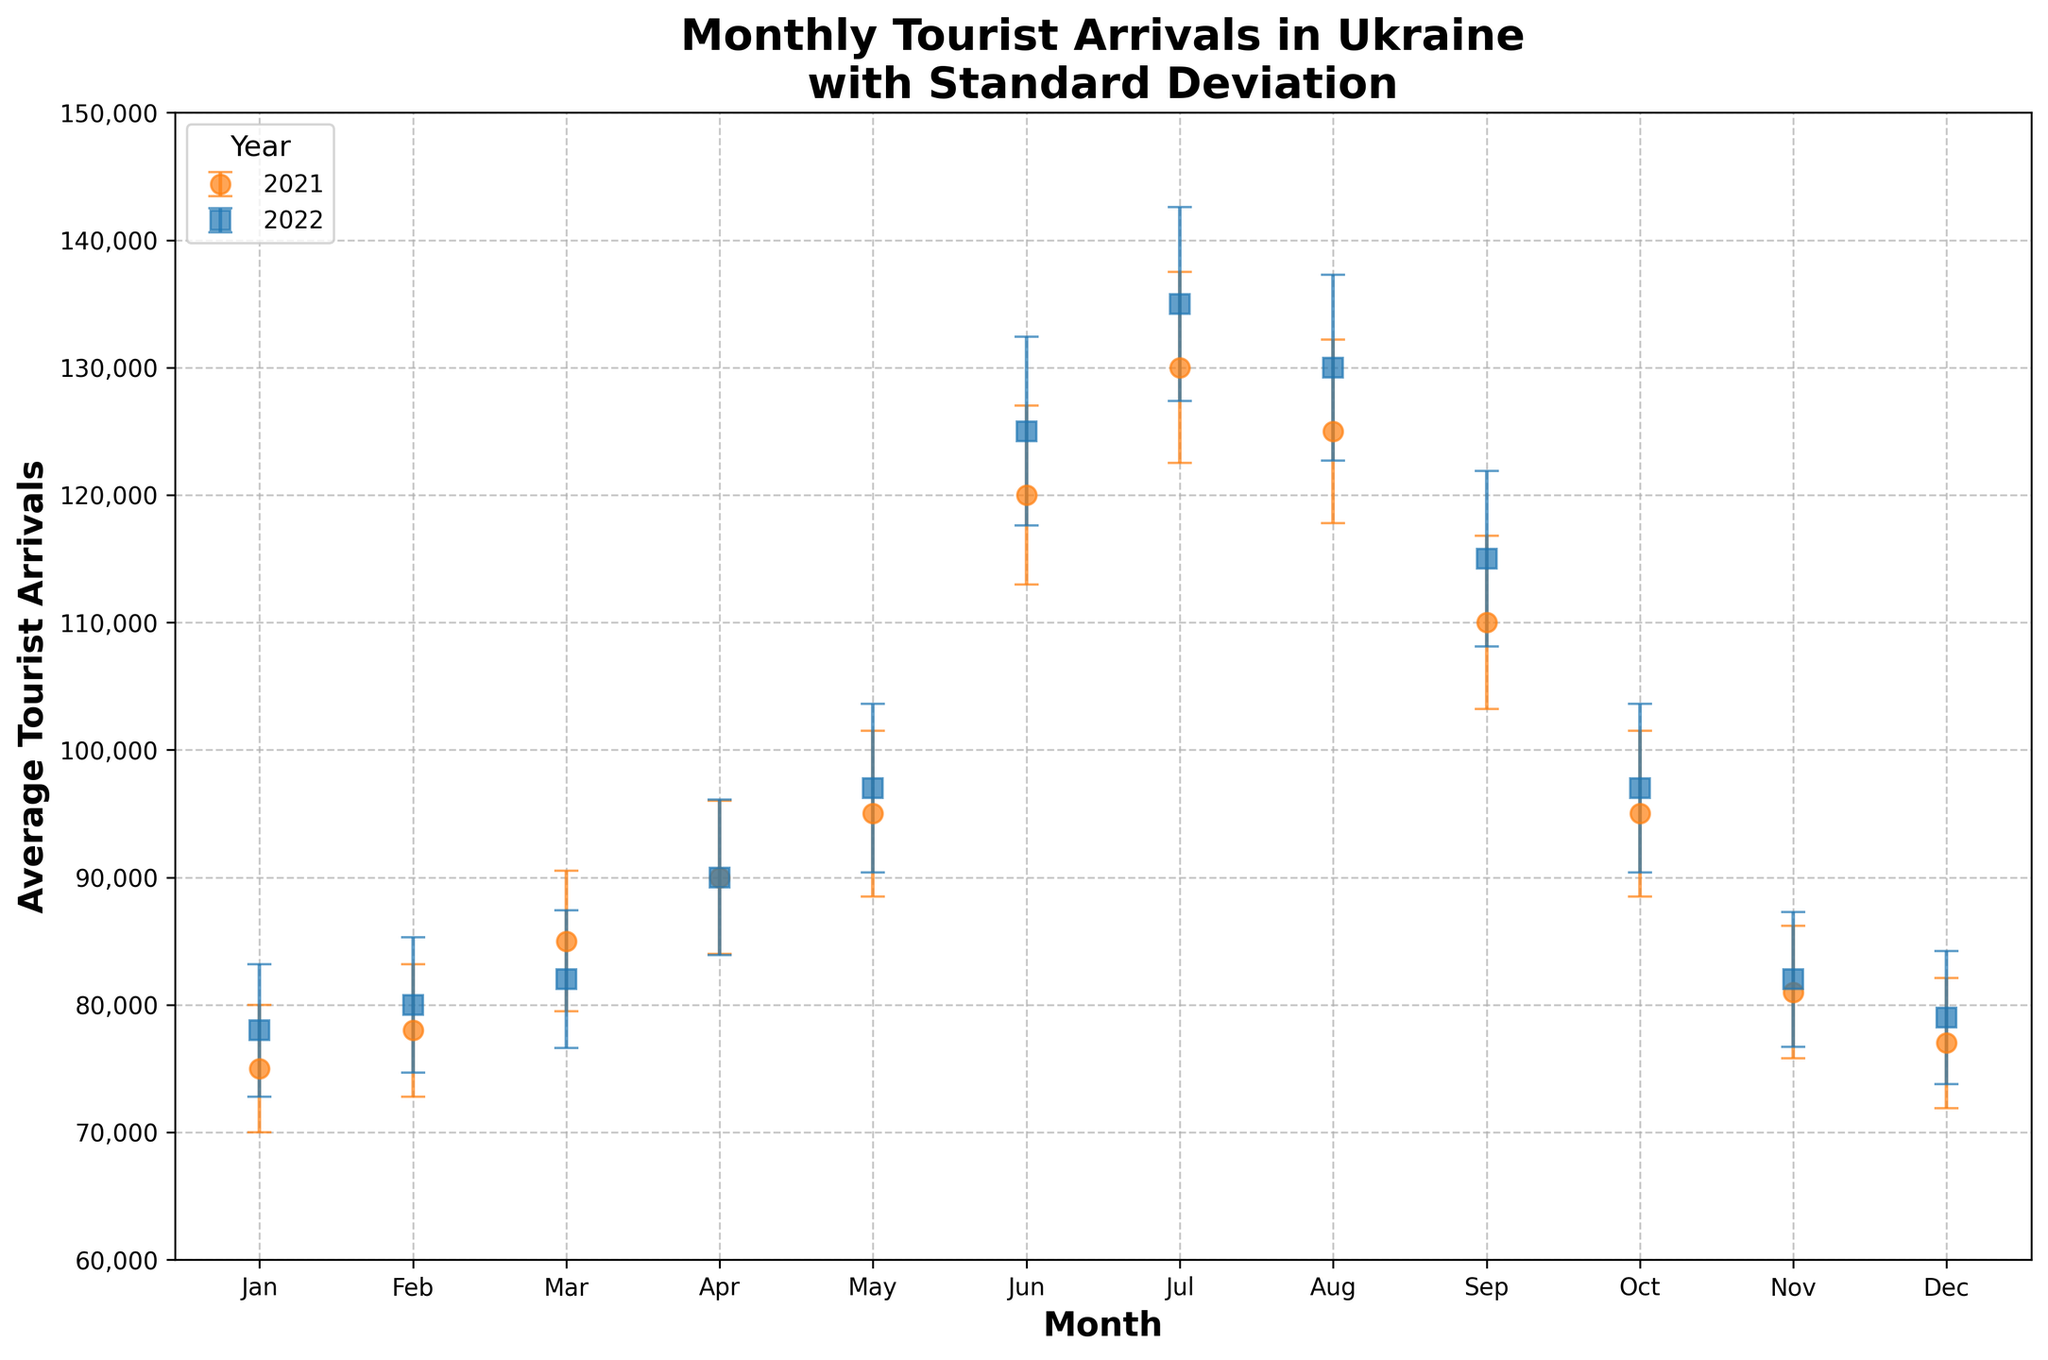what is the title of the figure? The title is typically at the top of the figure and summarizes the content. The title here is 'Monthly Tourist Arrivals in Ukraine with Standard Deviation'.
Answer: Monthly Tourist Arrivals in Ukraine with Standard Deviation How many years are presented in the figure? The figure showcases data for each year separately, indicated by different colors and markers in the legend. There are two years, 2021 and 2022.
Answer: 2 Which month had the highest average tourist arrivals in 2021? To find this, we look at the heights of the markers for each month in 2021. July had the highest, with an average of 130,000.
Answer: July Which year had a higher average tourist arrival in December? Compare the markers for December in both years. The height of the marker for 2021 is 77,000 while for 2022, it is 79,000. 2022 had higher average tourist arrivals in December.
Answer: 2022 How does the standard deviation in June compare between the two years? Look at the size of the error bars for June in both years. The standard deviation for June 2021 is smaller than that for June 2022 (7,000 vs. 7,400).
Answer: Smaller in 2021 What is the difference in average tourist arrivals in May between 2021 and 2022? Find the heights of the markers in May for both years and subtract the value for 2021 from 2022. 2022 has 97,000 and 2021 has 95,000, so the difference is 2,000.
Answer: 2,000 In which month did both years have identical average tourist arrivals? Compare the heights of the markers month-by-month for both years. April shows identical average tourist arrivals at 90,000 for both years.
Answer: April Which month shows the largest standard deviation in 2022, and what is the value? Look for the longest error bar in 2022. July shows the largest standard deviation with a value of 7,600.
Answer: July, 7,600 Are there any months where the error bars from both years overlap? Look for months where the vertical error bars intersect. January and February are examples where this overlap may occur.
Answer: January and February Considering the whole period, in which year did Ukraine see a higher monthly average tourist arrival in general? By observing most of the monthly markers and their respective heights, 2022 consistently shows higher average tourist arrivals compared to 2021, although specific months might differ.
Answer: 2022 